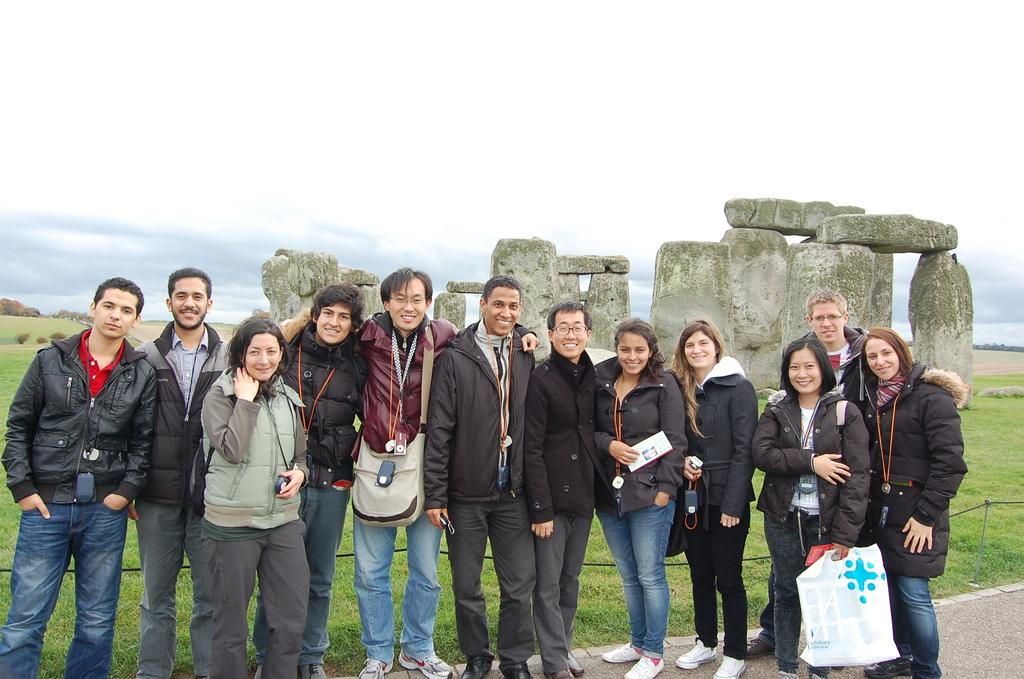How many people are in the image? There is a group of people in the image. What are the people doing in the image? The people are standing and smiling. What type of natural elements can be seen in the image? There are rocks, grass, and trees in the image. What is visible in the background of the image? The sky is visible in the background of the image. What type of flowers are growing in a circle around the people in the image? There are no flowers present in the image, and the people are not surrounded by a circle. 